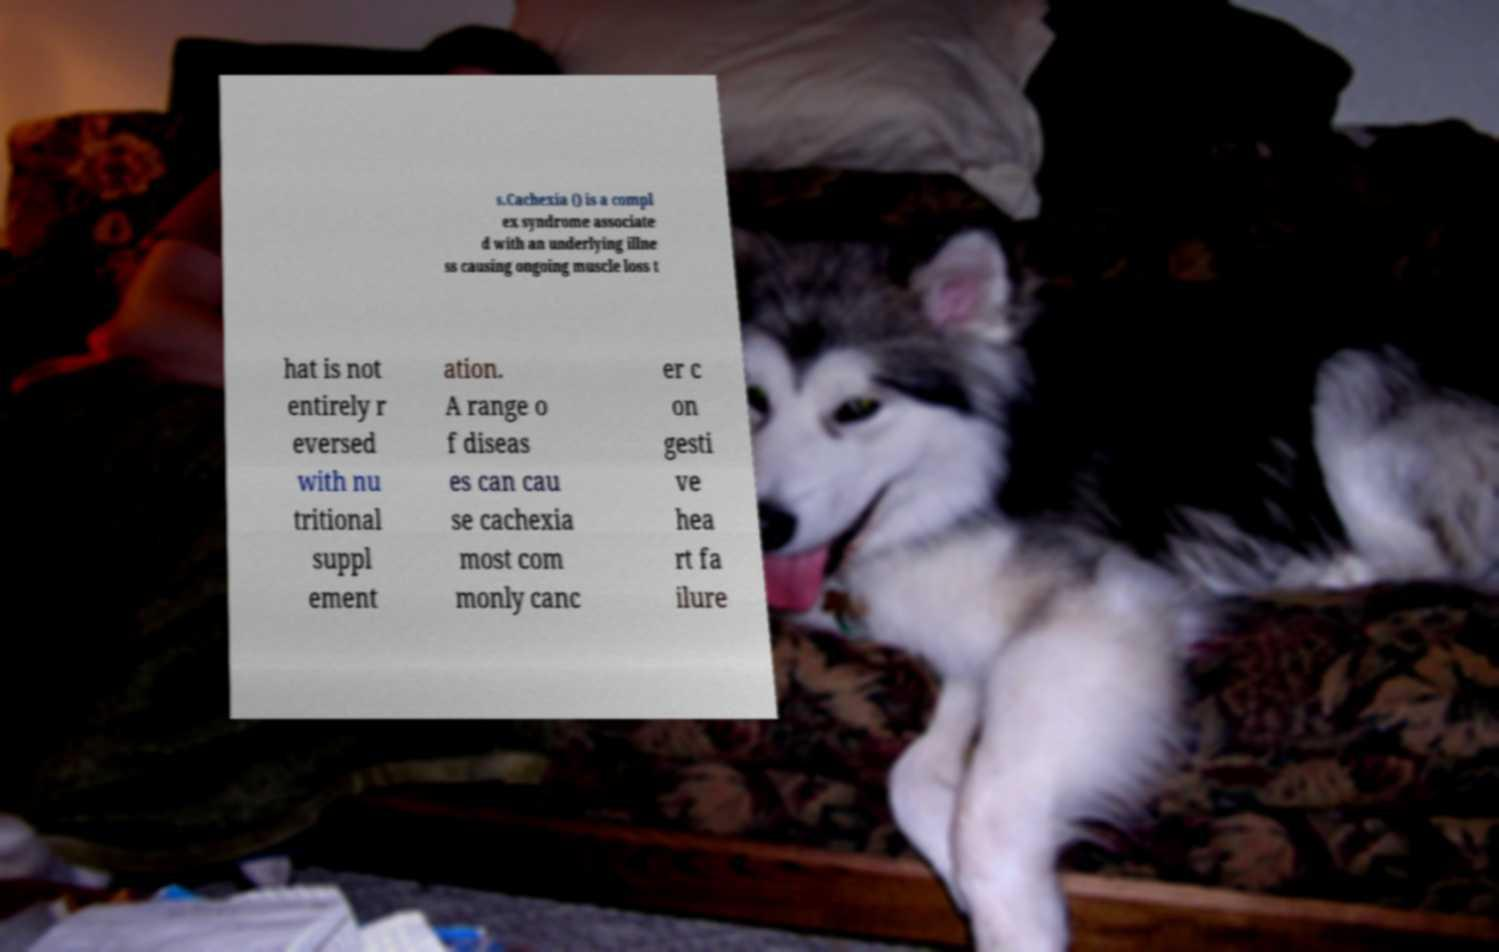I need the written content from this picture converted into text. Can you do that? s.Cachexia () is a compl ex syndrome associate d with an underlying illne ss causing ongoing muscle loss t hat is not entirely r eversed with nu tritional suppl ement ation. A range o f diseas es can cau se cachexia most com monly canc er c on gesti ve hea rt fa ilure 